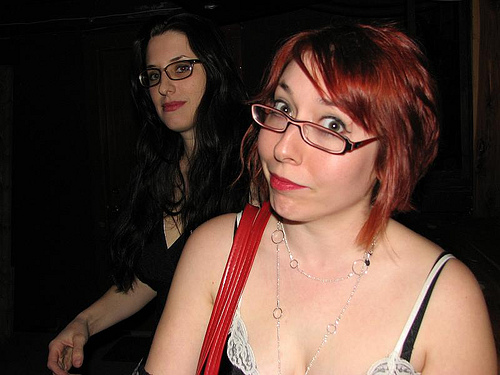<image>
Is the woman to the left of the woman? Yes. From this viewpoint, the woman is positioned to the left side relative to the woman. 